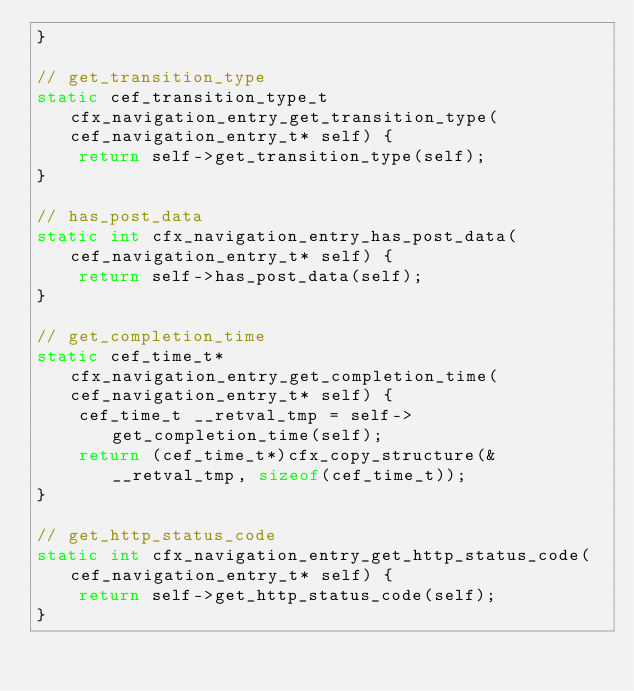<code> <loc_0><loc_0><loc_500><loc_500><_C_>}

// get_transition_type
static cef_transition_type_t cfx_navigation_entry_get_transition_type(cef_navigation_entry_t* self) {
    return self->get_transition_type(self);
}

// has_post_data
static int cfx_navigation_entry_has_post_data(cef_navigation_entry_t* self) {
    return self->has_post_data(self);
}

// get_completion_time
static cef_time_t* cfx_navigation_entry_get_completion_time(cef_navigation_entry_t* self) {
    cef_time_t __retval_tmp = self->get_completion_time(self);
    return (cef_time_t*)cfx_copy_structure(&__retval_tmp, sizeof(cef_time_t));
}

// get_http_status_code
static int cfx_navigation_entry_get_http_status_code(cef_navigation_entry_t* self) {
    return self->get_http_status_code(self);
}


</code> 